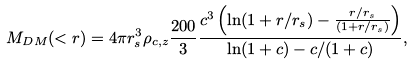<formula> <loc_0><loc_0><loc_500><loc_500>M _ { D M } ( < r ) = 4 \pi r _ { s } ^ { 3 } \rho _ { c , z } \frac { 2 0 0 } { 3 } \frac { c ^ { 3 } \left ( \ln ( 1 + r / r _ { s } ) - \frac { r / r _ { s } } { ( 1 + r / r _ { s } ) } \right ) } { \ln ( 1 + c ) - c / ( 1 + c ) } ,</formula> 